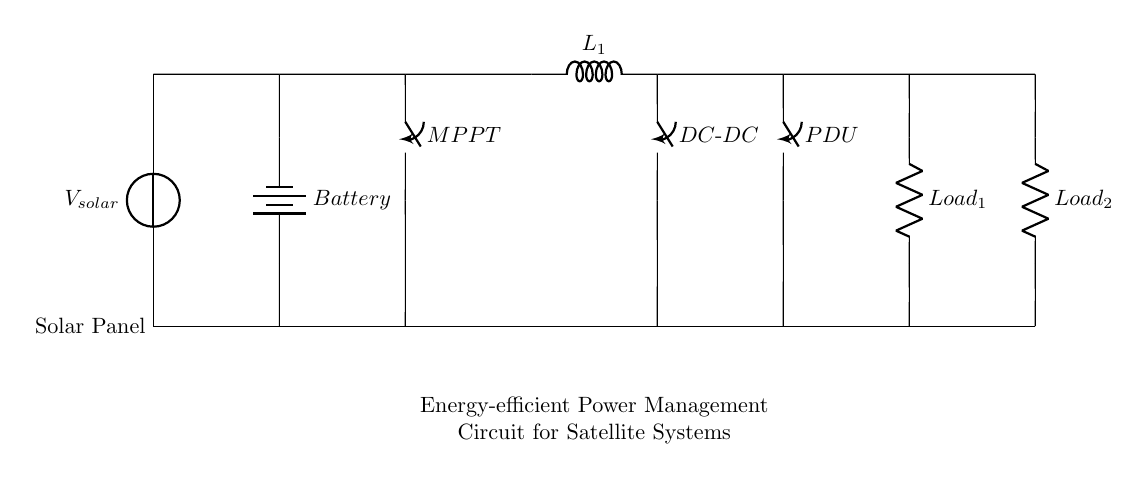What is the main source of power for this circuit? The solar panel is the main source of power, indicated by the voltage source labeled Vsolar at the beginning of the circuit.
Answer: solar panel What component is used to manage the power output from the solar panel? The Maximum Power Point Tracker (MPPT) manages the power output by optimizing the energy obtained from the solar panel, as shown between the solar panel and the battery.
Answer: MPPT How many loads are connected to the output of this power management circuit? There are two loads connected in the circuit, indicated as Load 1 and Load 2, which are resistors shown towards the right end of the circuit.
Answer: 2 What is the role of the battery in this circuit? The battery stores energy produced by the solar panel for use during periods when solar power is not available, as depicted below the solar panel and MPPT in the circuit.
Answer: energy storage Which component converts the voltage from the battery to the appropriate level for the loads? The DC-DC converter is responsible for converting the battery voltage to the right levels needed by the connected loads, shown right after the battery in the circuit path.
Answer: DC-DC converter What kind of circuit type is represented here? The circuit represents a power management circuit designed for energy efficiency in satellite systems, tailored to handle high power and incorporate renewable sources.
Answer: Power management circuit What does the inductor in the circuit do? The inductor, labeled L1, filters and smooths the current flow, minimizing voltage fluctuations, and is located after the MPPT before reaching the DC-DC converter.
Answer: current smoothing 